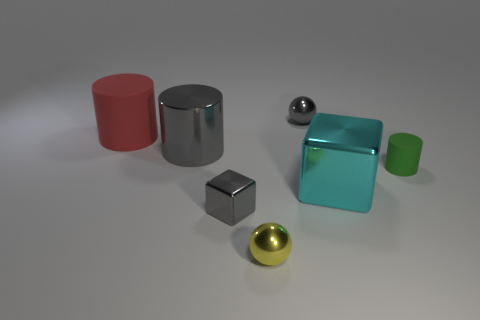Add 2 big purple matte balls. How many objects exist? 9 Subtract all cylinders. How many objects are left? 4 Subtract 0 brown cylinders. How many objects are left? 7 Subtract all small things. Subtract all big green cylinders. How many objects are left? 3 Add 3 cubes. How many cubes are left? 5 Add 4 red matte cylinders. How many red matte cylinders exist? 5 